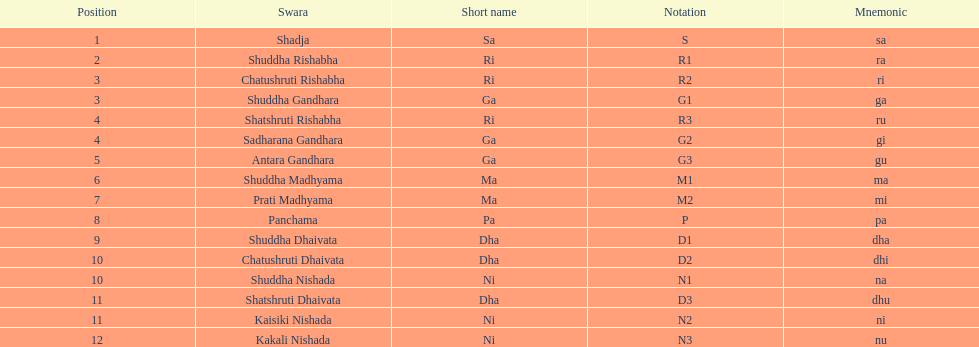Help me parse the entirety of this table. {'header': ['Position', 'Swara', 'Short name', 'Notation', 'Mnemonic'], 'rows': [['1', 'Shadja', 'Sa', 'S', 'sa'], ['2', 'Shuddha Rishabha', 'Ri', 'R1', 'ra'], ['3', 'Chatushruti Rishabha', 'Ri', 'R2', 'ri'], ['3', 'Shuddha Gandhara', 'Ga', 'G1', 'ga'], ['4', 'Shatshruti Rishabha', 'Ri', 'R3', 'ru'], ['4', 'Sadharana Gandhara', 'Ga', 'G2', 'gi'], ['5', 'Antara Gandhara', 'Ga', 'G3', 'gu'], ['6', 'Shuddha Madhyama', 'Ma', 'M1', 'ma'], ['7', 'Prati Madhyama', 'Ma', 'M2', 'mi'], ['8', 'Panchama', 'Pa', 'P', 'pa'], ['9', 'Shuddha Dhaivata', 'Dha', 'D1', 'dha'], ['10', 'Chatushruti Dhaivata', 'Dha', 'D2', 'dhi'], ['10', 'Shuddha Nishada', 'Ni', 'N1', 'na'], ['11', 'Shatshruti Dhaivata', 'Dha', 'D3', 'dhu'], ['11', 'Kaisiki Nishada', 'Ni', 'N2', 'ni'], ['12', 'Kakali Nishada', 'Ni', 'N3', 'nu']]} In how many swara names does dhaivata not appear? 13. 